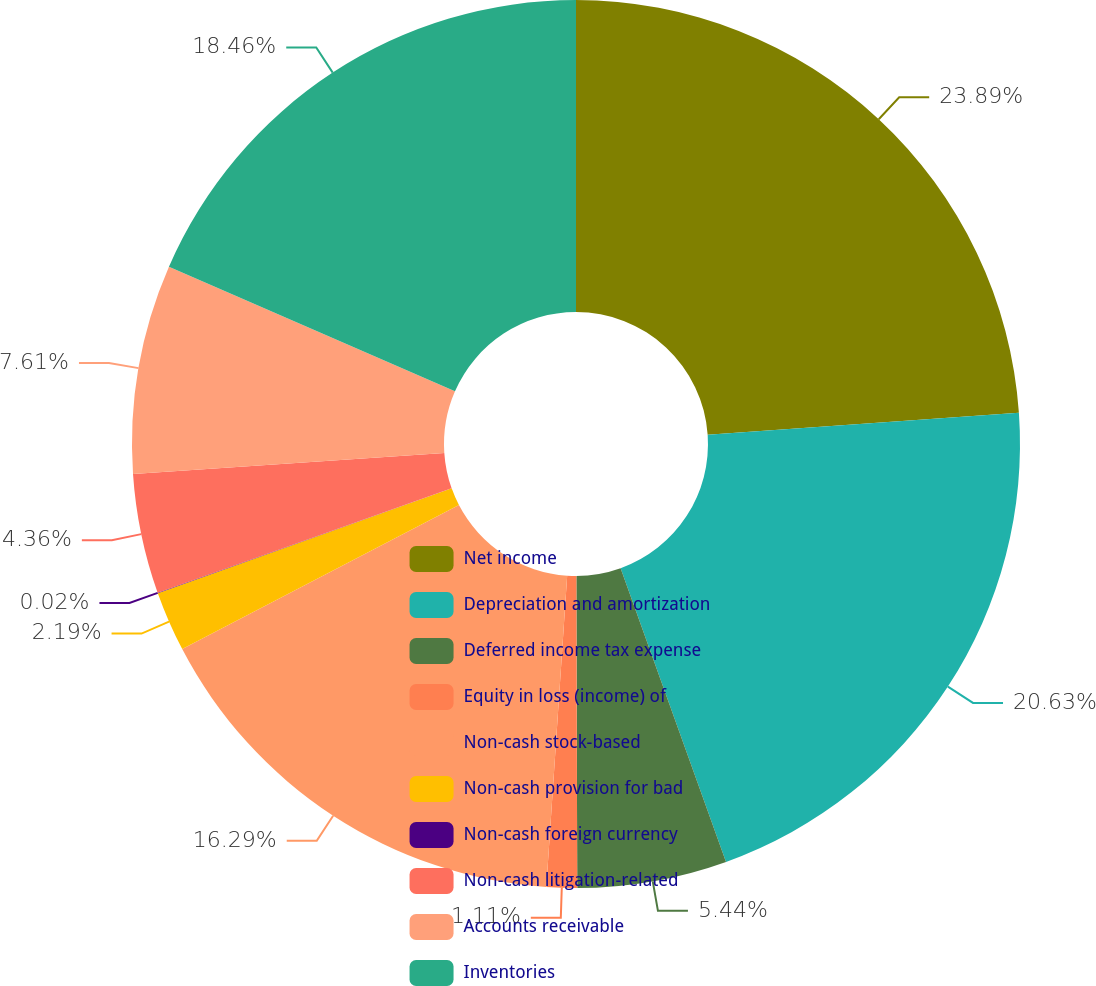<chart> <loc_0><loc_0><loc_500><loc_500><pie_chart><fcel>Net income<fcel>Depreciation and amortization<fcel>Deferred income tax expense<fcel>Equity in loss (income) of<fcel>Non-cash stock-based<fcel>Non-cash provision for bad<fcel>Non-cash foreign currency<fcel>Non-cash litigation-related<fcel>Accounts receivable<fcel>Inventories<nl><fcel>23.88%<fcel>20.63%<fcel>5.44%<fcel>1.11%<fcel>16.29%<fcel>2.19%<fcel>0.02%<fcel>4.36%<fcel>7.61%<fcel>18.46%<nl></chart> 